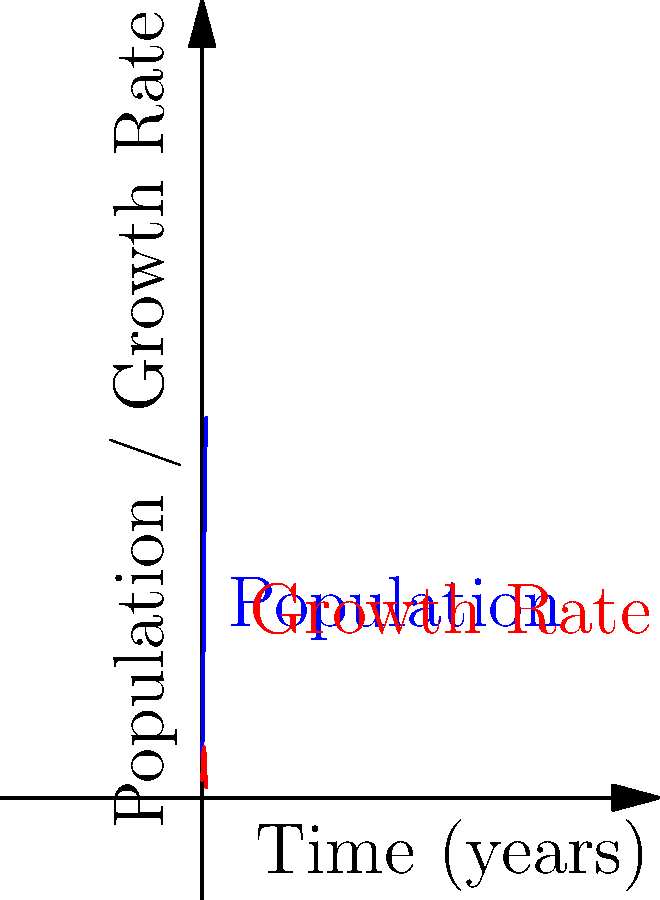The blue curve represents a population growth model given by the function $P(t) = \frac{1000}{1+9e^{-0.5t}}$, where $P$ is the population and $t$ is time in years. The red curve shows the rate of change of the population. At what time does the population growth rate reach its maximum value? To find the maximum growth rate, we need to follow these steps:

1) First, we need to find the derivative of $P(t)$, which represents the growth rate:
   $P'(t) = \frac{1000 \cdot 0.5 \cdot 9e^{-0.5t}}{(1+9e^{-0.5t})^2}$

2) To find the maximum of $P'(t)$, we need to find where its derivative equals zero:
   $P''(t) = \frac{1000 \cdot 0.5 \cdot 9e^{-0.5t}(9e^{-0.5t}-1)}{(1+9e^{-0.5t})^3} \cdot (-0.5) = 0$

3) Solving this equation:
   $9e^{-0.5t}-1 = 0$
   $9e^{-0.5t} = 1$
   $e^{-0.5t} = \frac{1}{9}$
   $-0.5t = \ln(\frac{1}{9}) = -\ln(9)$
   $t = \frac{2\ln(9)}{1} = 2\ln(9) \approx 4.39$ years

4) We can confirm this is a maximum by checking the sign of $P''(t)$ before and after this point, or by observing the graph.

Therefore, the population growth rate reaches its maximum value when $t = 2\ln(9)$, or approximately 4.39 years.
Answer: $2\ln(9)$ years 